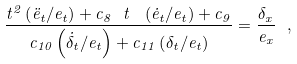Convert formula to latex. <formula><loc_0><loc_0><loc_500><loc_500>\frac { t ^ { 2 } \left ( \ddot { e } _ { t } / e _ { t } \right ) + c _ { 8 } \ t \ \left ( \dot { e } _ { t } / e _ { t } \right ) + c _ { 9 } } { c _ { 1 0 } \left ( \dot { \delta } _ { t } / e _ { t } \right ) + c _ { 1 1 } \left ( \delta _ { t } / e _ { t } \right ) } = \frac { \delta _ { x } } { e _ { x } } \ ,</formula> 